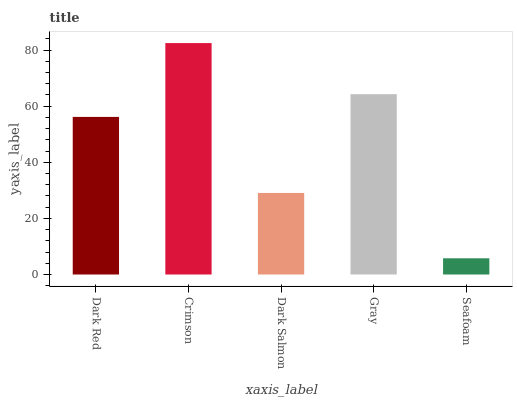Is Seafoam the minimum?
Answer yes or no. Yes. Is Crimson the maximum?
Answer yes or no. Yes. Is Dark Salmon the minimum?
Answer yes or no. No. Is Dark Salmon the maximum?
Answer yes or no. No. Is Crimson greater than Dark Salmon?
Answer yes or no. Yes. Is Dark Salmon less than Crimson?
Answer yes or no. Yes. Is Dark Salmon greater than Crimson?
Answer yes or no. No. Is Crimson less than Dark Salmon?
Answer yes or no. No. Is Dark Red the high median?
Answer yes or no. Yes. Is Dark Red the low median?
Answer yes or no. Yes. Is Crimson the high median?
Answer yes or no. No. Is Dark Salmon the low median?
Answer yes or no. No. 